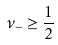Convert formula to latex. <formula><loc_0><loc_0><loc_500><loc_500>\nu _ { - } \geq \frac { 1 } { 2 }</formula> 